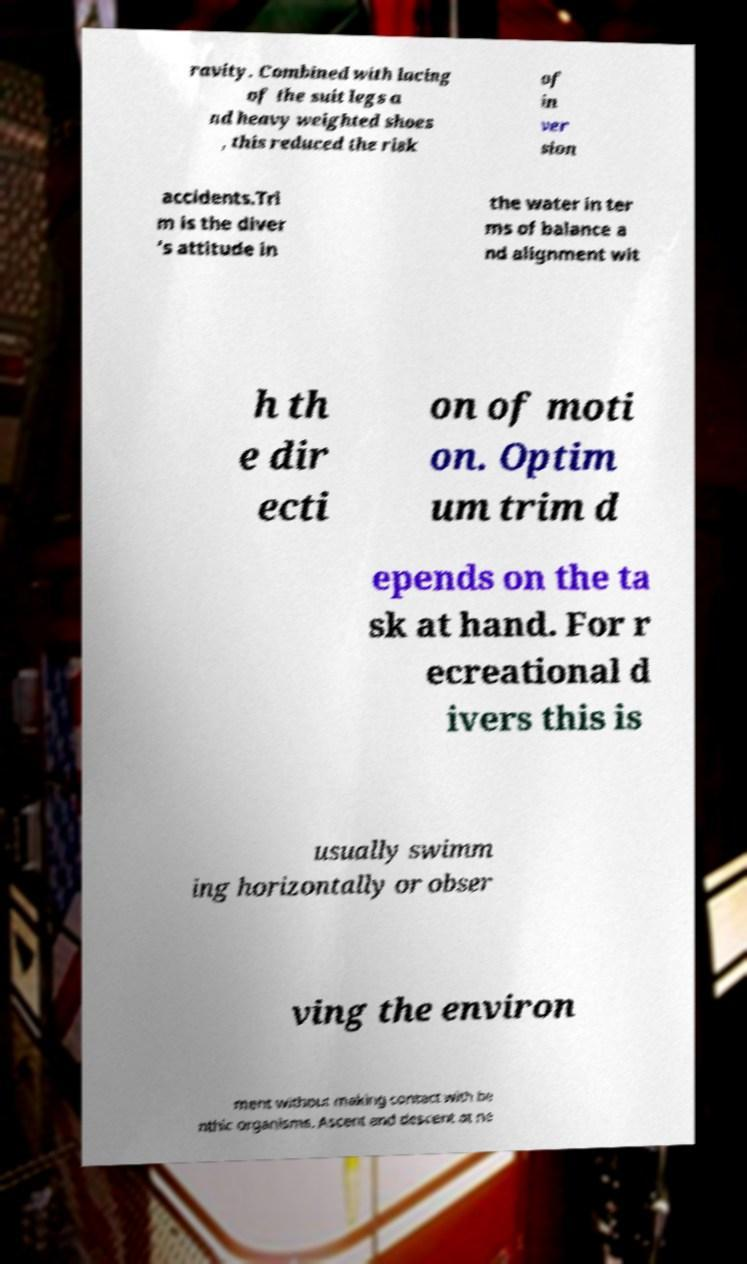Please identify and transcribe the text found in this image. ravity. Combined with lacing of the suit legs a nd heavy weighted shoes , this reduced the risk of in ver sion accidents.Tri m is the diver 's attitude in the water in ter ms of balance a nd alignment wit h th e dir ecti on of moti on. Optim um trim d epends on the ta sk at hand. For r ecreational d ivers this is usually swimm ing horizontally or obser ving the environ ment without making contact with be nthic organisms. Ascent and descent at ne 